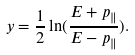<formula> <loc_0><loc_0><loc_500><loc_500>y = \frac { 1 } { 2 } \ln ( \frac { E + p _ { \| } } { E - p _ { \| } } ) .</formula> 